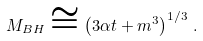Convert formula to latex. <formula><loc_0><loc_0><loc_500><loc_500>M _ { B H } \cong \left ( 3 \alpha t + m ^ { 3 } \right ) ^ { 1 / 3 } \, .</formula> 